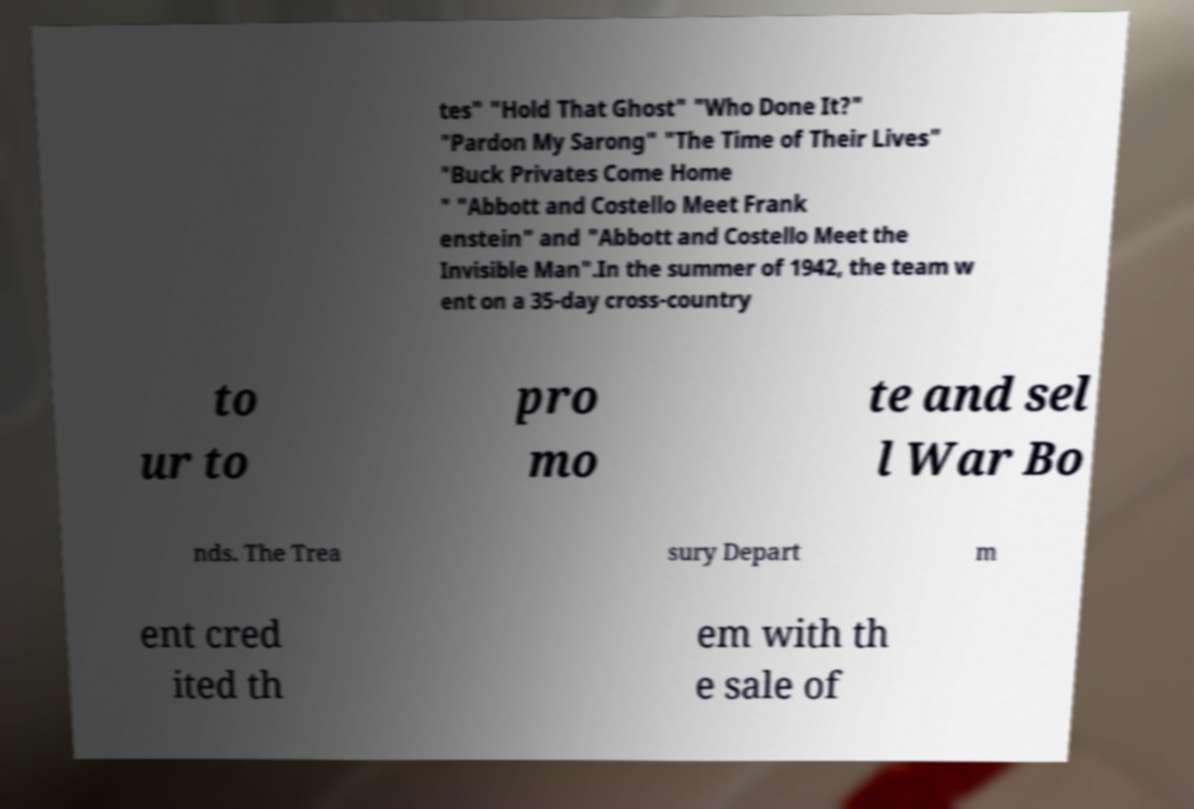Can you accurately transcribe the text from the provided image for me? tes" "Hold That Ghost" "Who Done It?" "Pardon My Sarong" "The Time of Their Lives" "Buck Privates Come Home " "Abbott and Costello Meet Frank enstein" and "Abbott and Costello Meet the Invisible Man".In the summer of 1942, the team w ent on a 35-day cross-country to ur to pro mo te and sel l War Bo nds. The Trea sury Depart m ent cred ited th em with th e sale of 